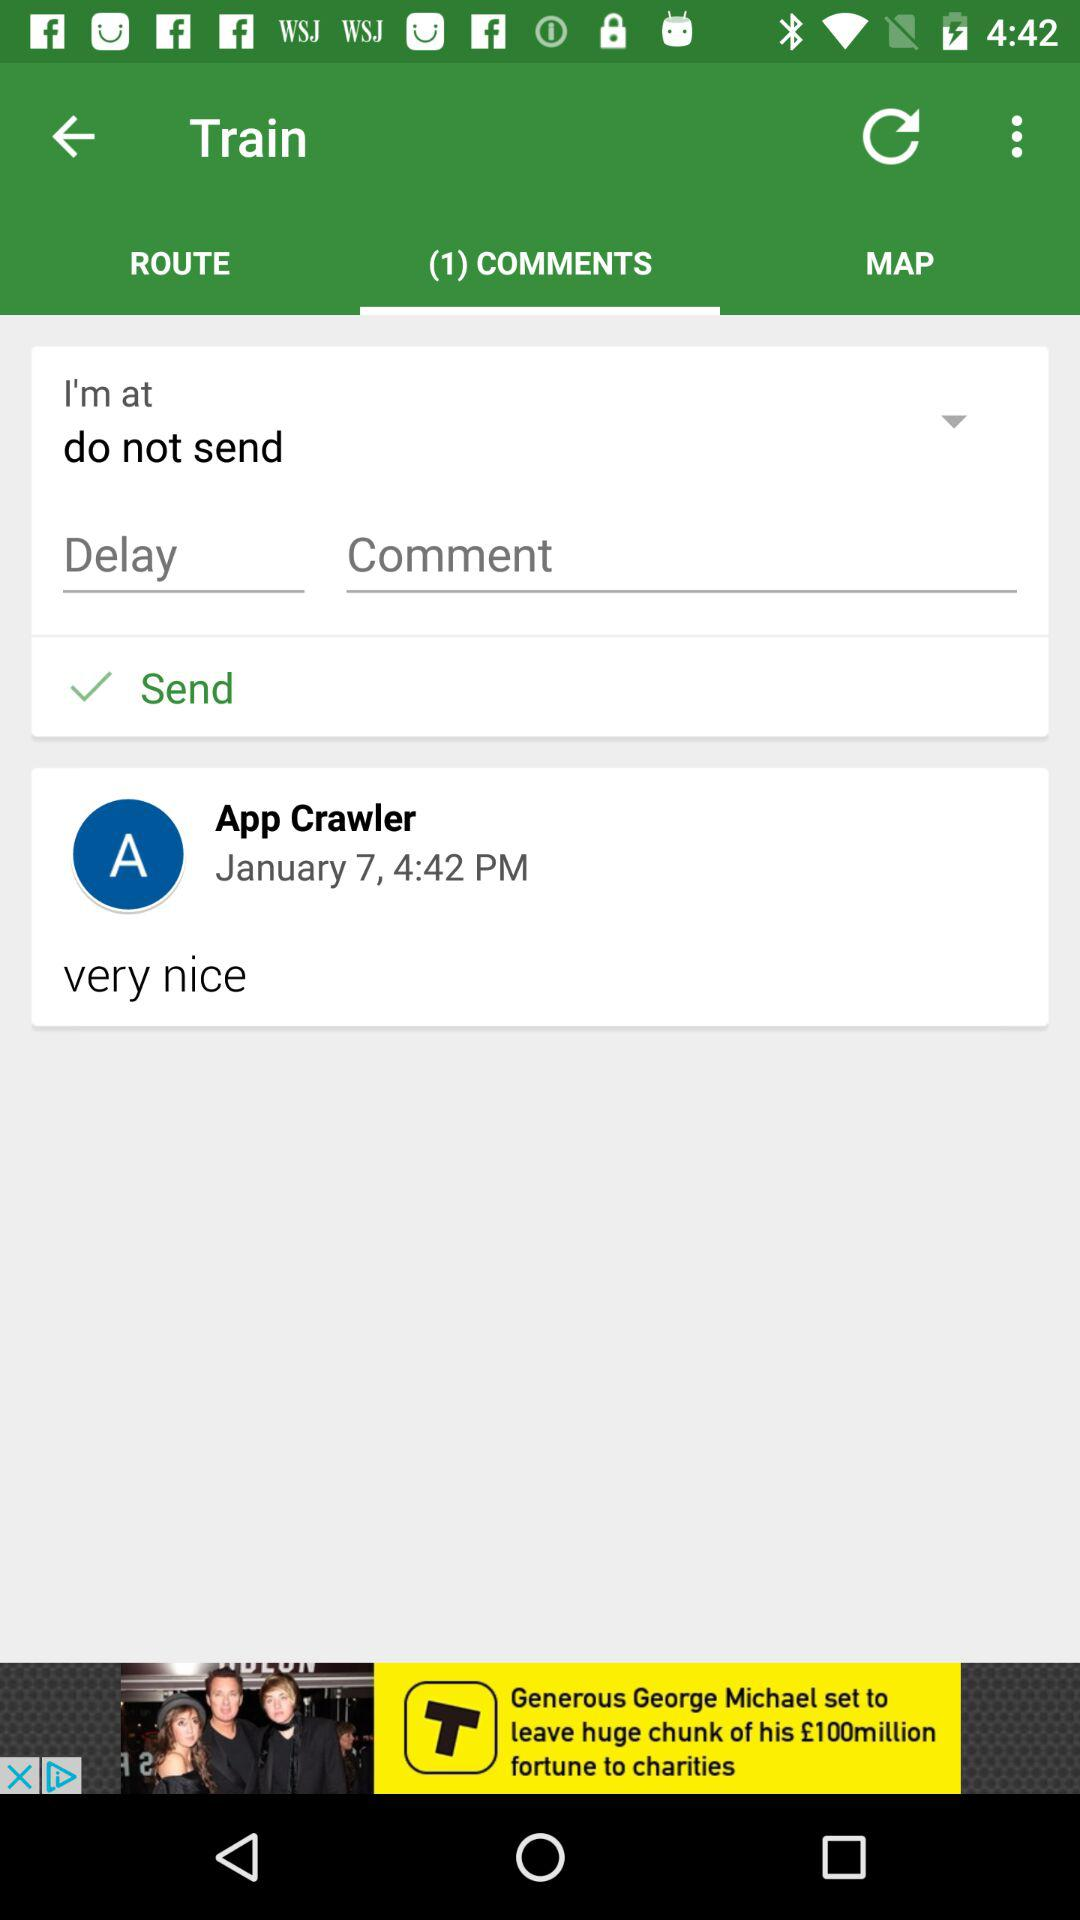How many comments are there on this screen?
Answer the question using a single word or phrase. 1 